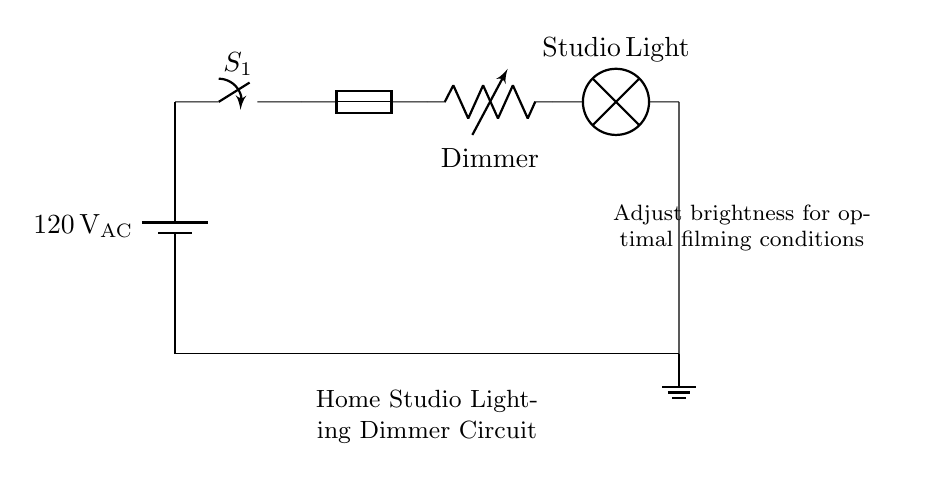What is the voltage of this circuit? The circuit diagram shows a battery labeled with a voltage of 120 volts AC, indicating the power source for the circuit.
Answer: 120 volts AC What type of component is the dimmer? The dimmer in the circuit is indicated as a variable resistor, which allows for adjusting the resistance and thereby controlling the brightness of the light bulb.
Answer: Variable resistor How many main components are in this circuit? The diagram shows five main components: the battery, switch, fuse, dimmer, and lamp. By counting each distinct part shown, we find the total.
Answer: Five What happens when the switch is open? If the switch is open, it creates a break in the circuit, preventing current from flowing, which means the lamp will not illuminate. This affects the entire operation of the lighting system.
Answer: The light will not illuminate What is the purpose of the fuse in this circuit? The fuse is a safety device designed to protect the circuit from overcurrent which could cause overheating or damage to components. By interrupting the circuit when excess current flows, it helps to ensure safety.
Answer: To protect from overcurrent What does the dimmer control? The dimmer is responsible for controlling the brightness of the studio light by varying the resistance in the circuit, which in turn modulates the current flowing to the lamp.
Answer: Brightness of the studio light Where does the current flow after the dimmer? After passing through the dimmer, the current continues to flow to the studio light, where it is converted to light energy. Following this, it returns to ground, completing the circuit.
Answer: To the studio light 